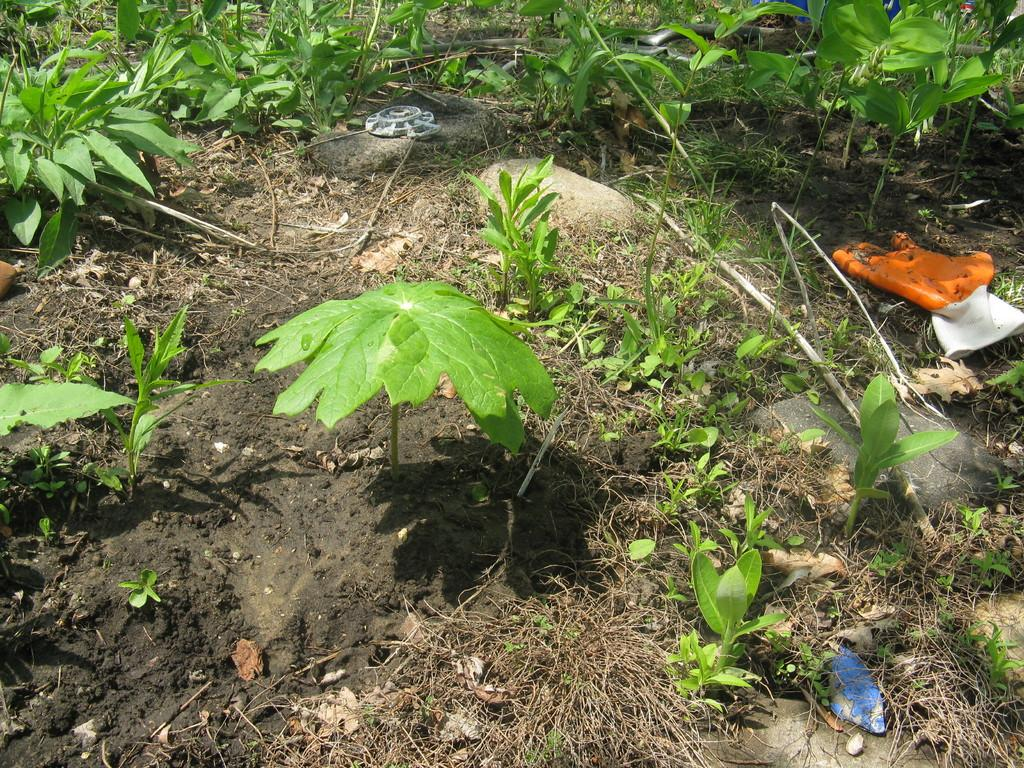What type of vegetation can be seen in the image? There are plants and grass in the image. What other objects are present in the image besides vegetation? There are stones in the image. What type of bike can be seen in the image? There is no bike present in the image. What kind of feast is being prepared in the image? There is no feast or any indication of food preparation in the image. 